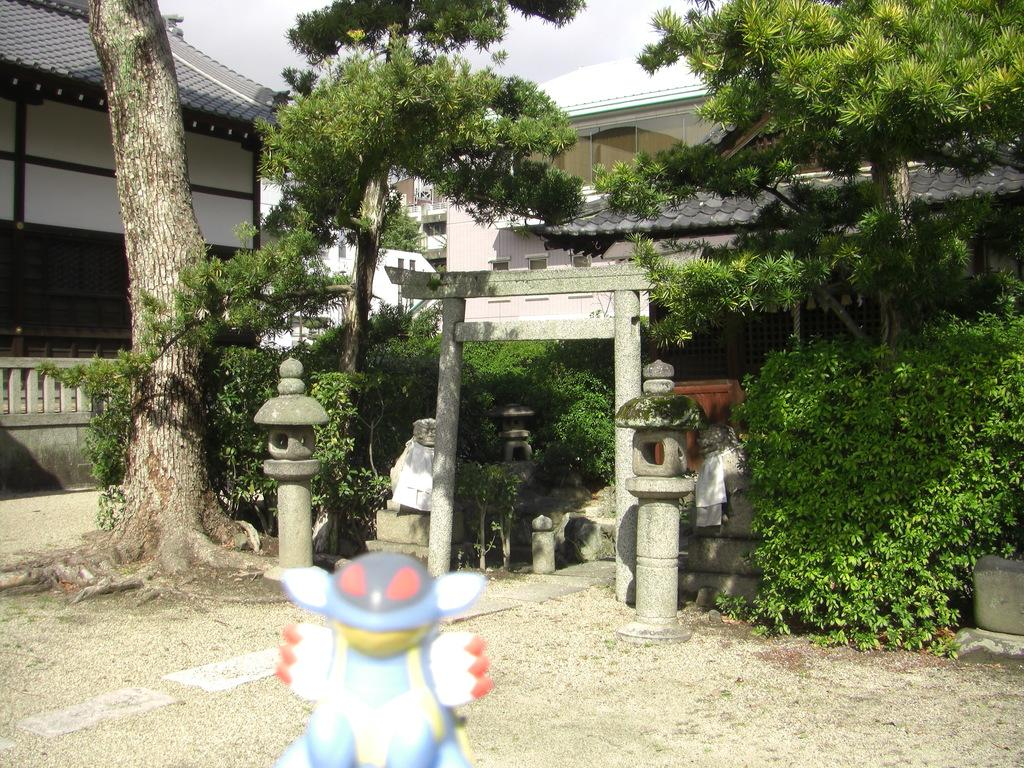What is located in the foreground of the image? There is a toy in the foreground of the image. What type of structure can be seen in the background of the image? There is a stone entrance in the background of the image. What other elements are present in the background of the image? There are poles, trees, houses, and a cloud visible in the background of the image. What type of butter is being used to paint the building in the image? There is no butter or building present in the image. 